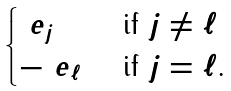Convert formula to latex. <formula><loc_0><loc_0><loc_500><loc_500>\begin{cases} \ e _ { j } & \text { if $j \neq \ell$} \\ - \ e _ { \ell } & \text { if $j = \ell$.} \end{cases}</formula> 